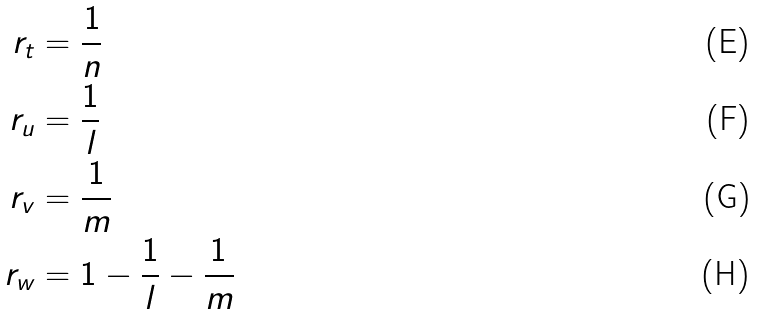<formula> <loc_0><loc_0><loc_500><loc_500>r _ { t } & = \frac { 1 } { n } \\ r _ { u } & = \frac { 1 } { l } \\ r _ { v } & = \frac { 1 } { m } \\ r _ { w } & = 1 - \frac { 1 } { l } - \frac { 1 } { m }</formula> 